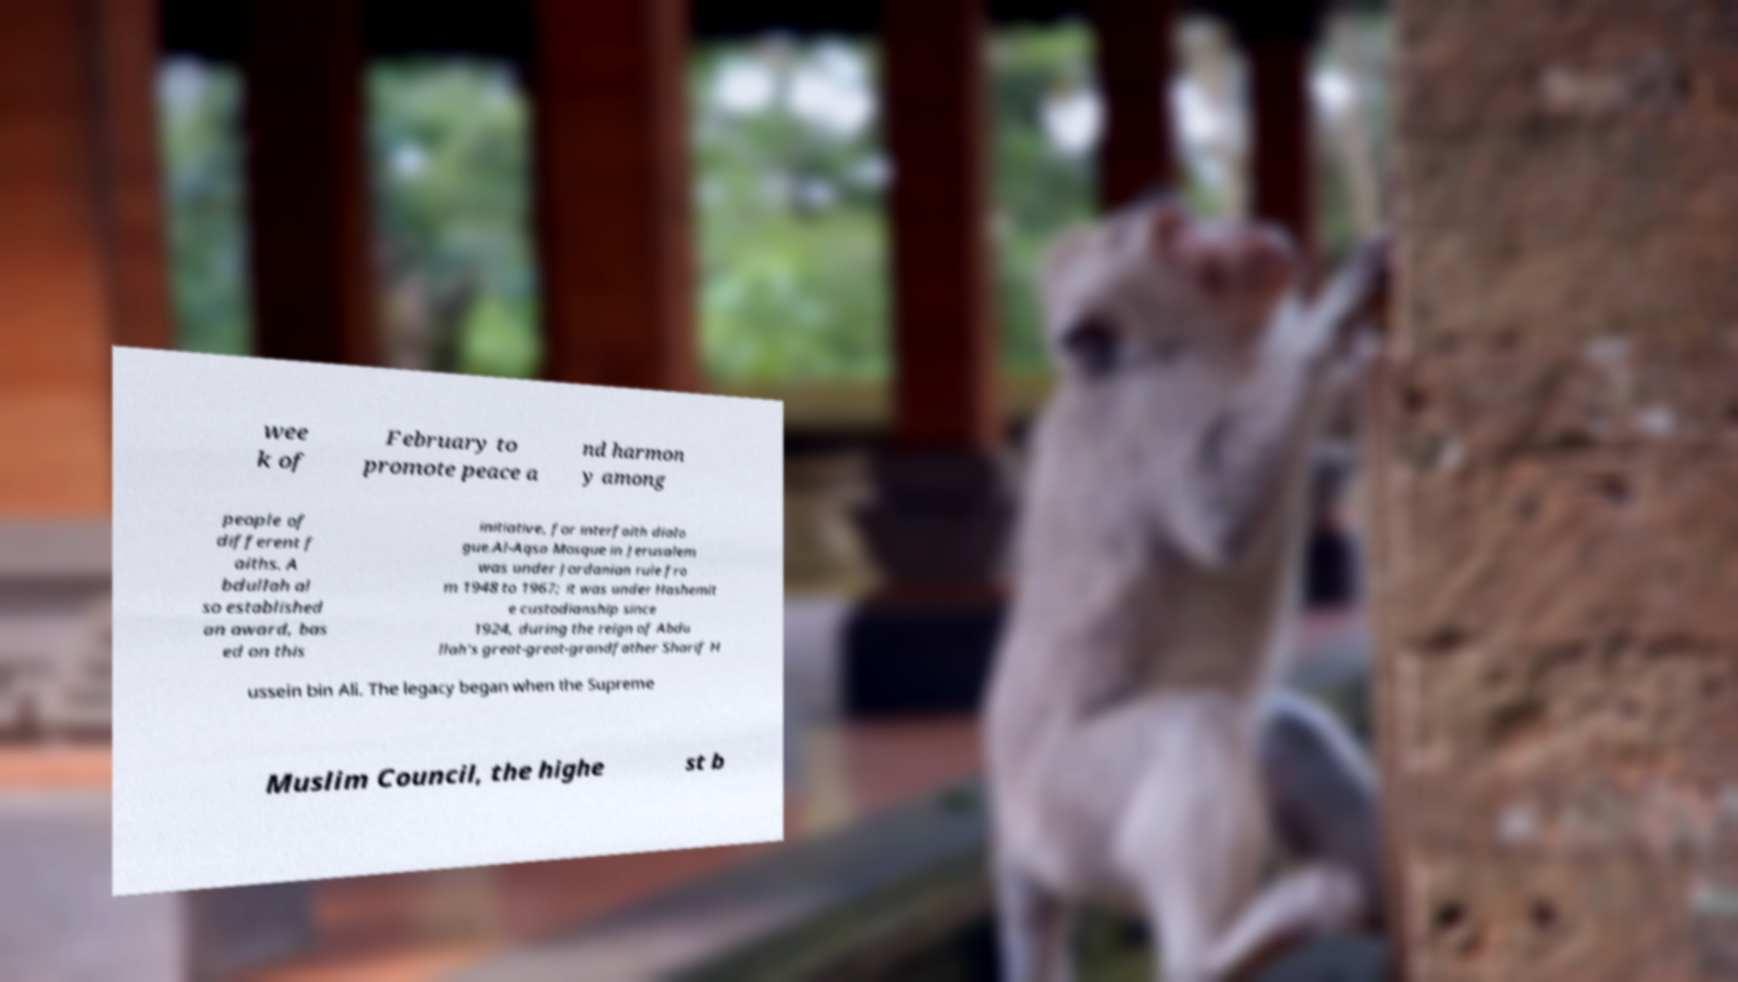Could you assist in decoding the text presented in this image and type it out clearly? wee k of February to promote peace a nd harmon y among people of different f aiths. A bdullah al so established an award, bas ed on this initiative, for interfaith dialo gue.Al-Aqsa Mosque in Jerusalem was under Jordanian rule fro m 1948 to 1967; it was under Hashemit e custodianship since 1924, during the reign of Abdu llah's great-great-grandfather Sharif H ussein bin Ali. The legacy began when the Supreme Muslim Council, the highe st b 